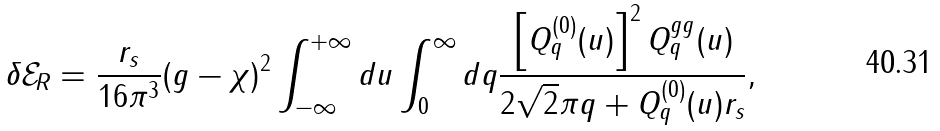Convert formula to latex. <formula><loc_0><loc_0><loc_500><loc_500>\delta \mathcal { E } _ { R } = \frac { r _ { s } } { 1 6 \pi ^ { 3 } } ( g - \chi ) ^ { 2 } \int _ { - \infty } ^ { + \infty } d u \int _ { 0 } ^ { \infty } d q \frac { \left [ Q ^ { ( 0 ) } _ { q } ( u ) \right ] ^ { 2 } Q ^ { g g } _ { q } ( u ) } { 2 \sqrt { 2 } \pi q + Q ^ { ( 0 ) } _ { q } ( u ) r _ { s } } ,</formula> 